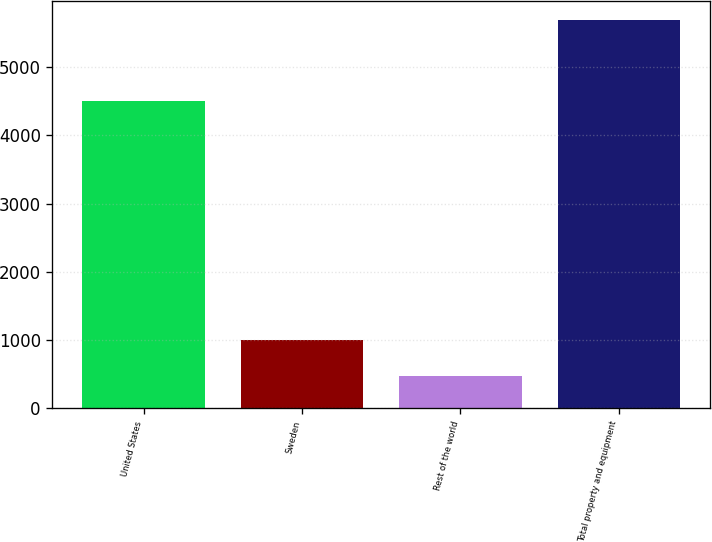Convert chart. <chart><loc_0><loc_0><loc_500><loc_500><bar_chart><fcel>United States<fcel>Sweden<fcel>Rest of the world<fcel>Total property and equipment<nl><fcel>4498<fcel>997.1<fcel>476<fcel>5687<nl></chart> 